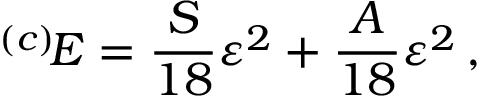<formula> <loc_0><loc_0><loc_500><loc_500>{ } ^ { ( c ) } \, E = \frac { S } { 1 8 } \varepsilon ^ { 2 } + \frac { A } { 1 8 } \varepsilon ^ { 2 } \, ,</formula> 